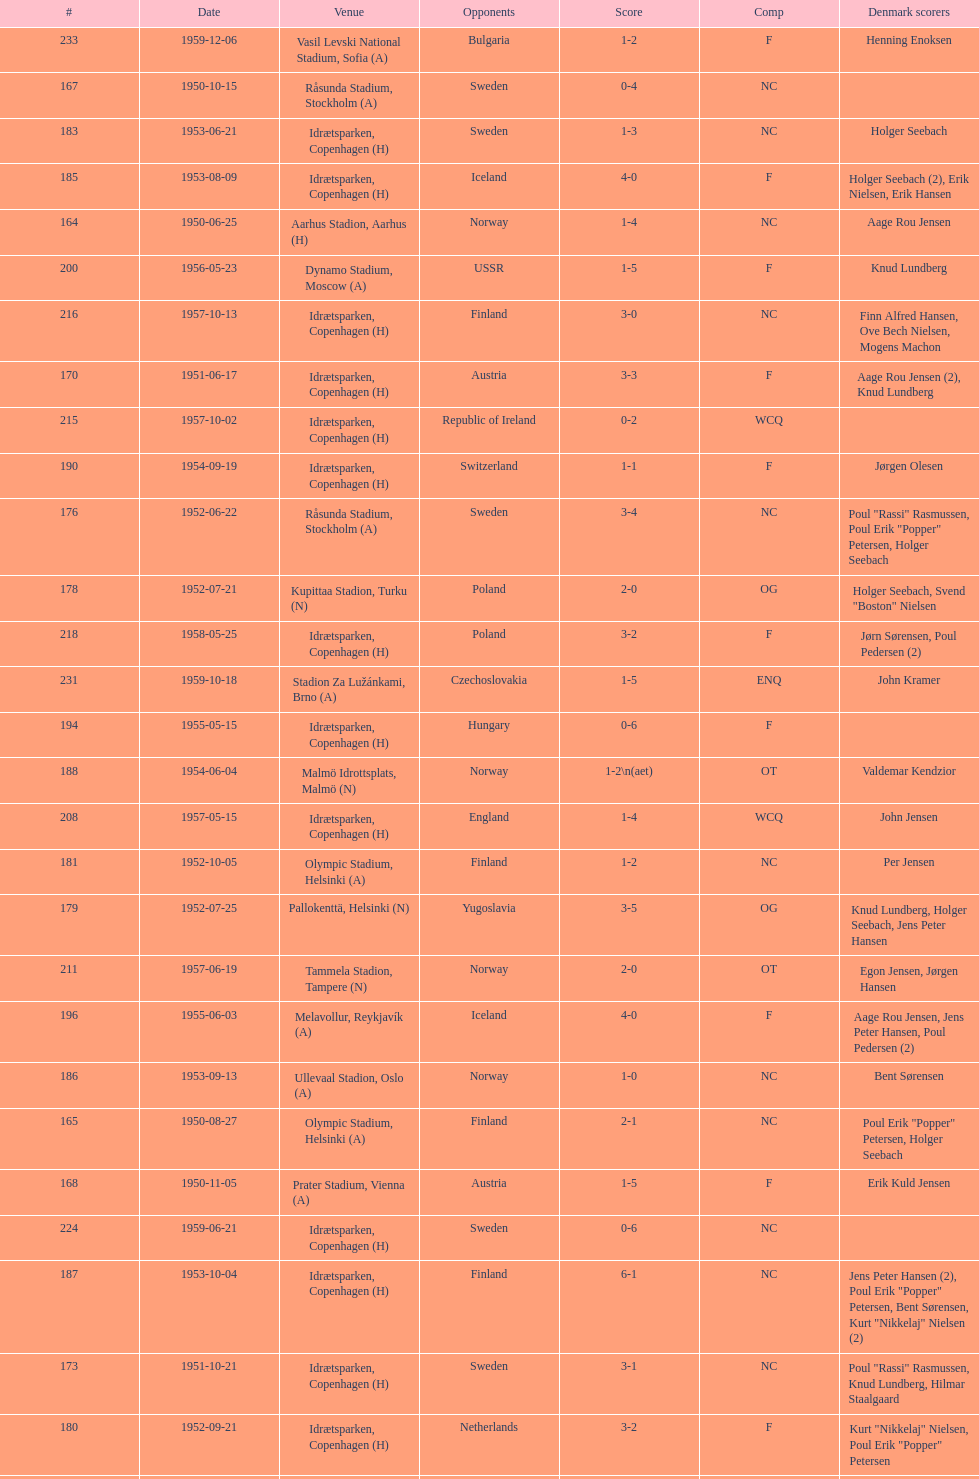Which total score was higher, game #163 or #181? 163. 